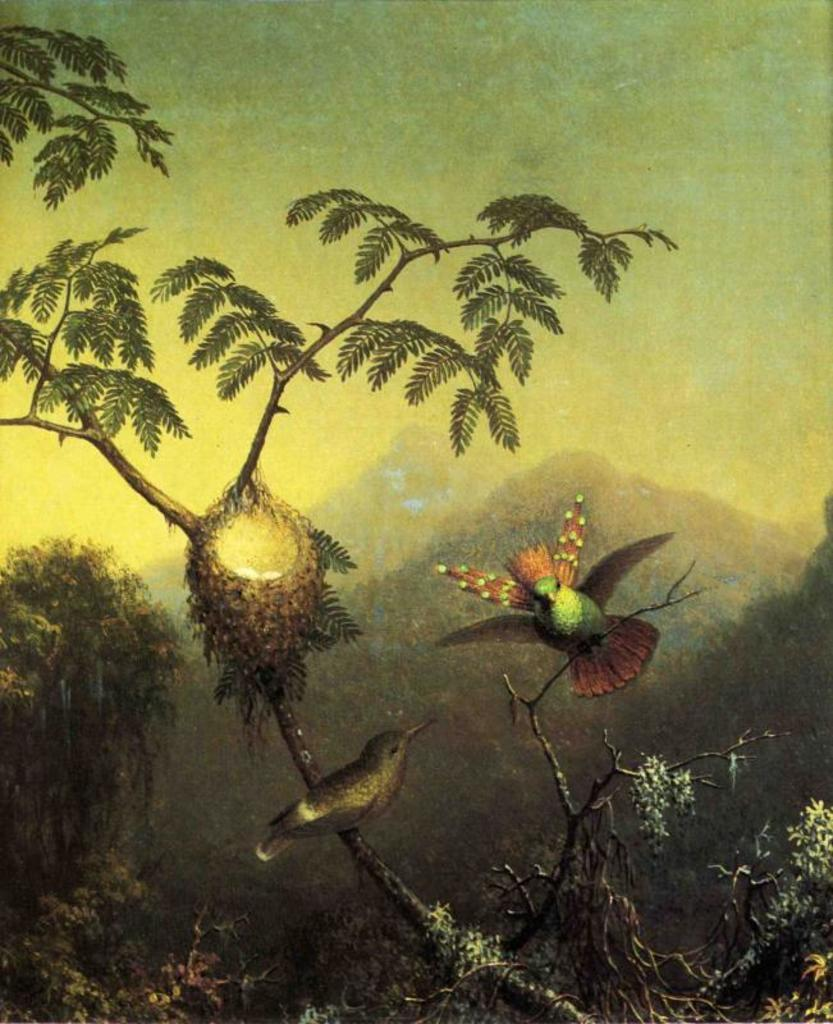What is the main subject of the image? There is a painting in the image. What is depicted in the painting? The painting depicts a nest on a tree. How many birds are in the painting? There are two birds in the painting. Where are the birds located in relation to the tree? The birds are sitting on the stem of the tree. What type of advice can be heard from the birds in the painting? There is no dialogue or communication between the birds in the painting, so no advice can be heard. 